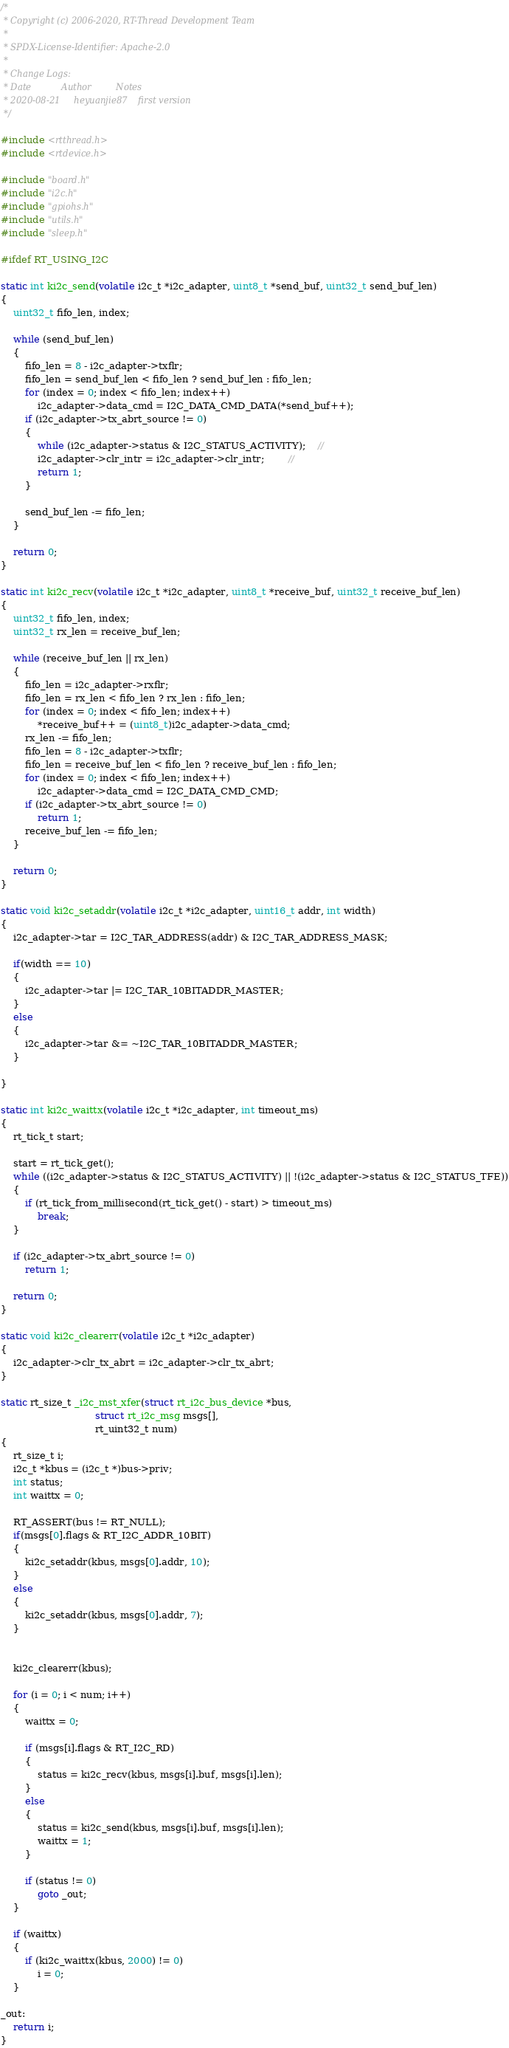Convert code to text. <code><loc_0><loc_0><loc_500><loc_500><_C_>/*
 * Copyright (c) 2006-2020, RT-Thread Development Team
 *
 * SPDX-License-Identifier: Apache-2.0
 *
 * Change Logs:
 * Date           Author         Notes
 * 2020-08-21     heyuanjie87    first version
 */

#include <rtthread.h>
#include <rtdevice.h>

#include "board.h"
#include "i2c.h"
#include "gpiohs.h"
#include "utils.h"
#include "sleep.h"

#ifdef RT_USING_I2C

static int ki2c_send(volatile i2c_t *i2c_adapter, uint8_t *send_buf, uint32_t send_buf_len)
{
    uint32_t fifo_len, index;

    while (send_buf_len)
    {
        fifo_len = 8 - i2c_adapter->txflr;
        fifo_len = send_buf_len < fifo_len ? send_buf_len : fifo_len;
        for (index = 0; index < fifo_len; index++)
            i2c_adapter->data_cmd = I2C_DATA_CMD_DATA(*send_buf++);
        if (i2c_adapter->tx_abrt_source != 0)
        {
            while (i2c_adapter->status & I2C_STATUS_ACTIVITY);	//
            i2c_adapter->clr_intr = i2c_adapter->clr_intr;		//
            return 1;
        }

        send_buf_len -= fifo_len;
    }

    return 0;
}

static int ki2c_recv(volatile i2c_t *i2c_adapter, uint8_t *receive_buf, uint32_t receive_buf_len)
{
    uint32_t fifo_len, index;
    uint32_t rx_len = receive_buf_len;

    while (receive_buf_len || rx_len)
    {
        fifo_len = i2c_adapter->rxflr;
        fifo_len = rx_len < fifo_len ? rx_len : fifo_len;
        for (index = 0; index < fifo_len; index++)
            *receive_buf++ = (uint8_t)i2c_adapter->data_cmd;
        rx_len -= fifo_len;
        fifo_len = 8 - i2c_adapter->txflr;
        fifo_len = receive_buf_len < fifo_len ? receive_buf_len : fifo_len;
        for (index = 0; index < fifo_len; index++)
            i2c_adapter->data_cmd = I2C_DATA_CMD_CMD;
        if (i2c_adapter->tx_abrt_source != 0)
            return 1;
        receive_buf_len -= fifo_len;
    }

    return 0;
}

static void ki2c_setaddr(volatile i2c_t *i2c_adapter, uint16_t addr, int width)
{
    i2c_adapter->tar = I2C_TAR_ADDRESS(addr) & I2C_TAR_ADDRESS_MASK;

    if(width == 10)
    {
        i2c_adapter->tar |= I2C_TAR_10BITADDR_MASTER;
    }
    else
    {
        i2c_adapter->tar &= ~I2C_TAR_10BITADDR_MASTER;
    }
    
}

static int ki2c_waittx(volatile i2c_t *i2c_adapter, int timeout_ms)
{
    rt_tick_t start;

    start = rt_tick_get();
    while ((i2c_adapter->status & I2C_STATUS_ACTIVITY) || !(i2c_adapter->status & I2C_STATUS_TFE))
    {
        if (rt_tick_from_millisecond(rt_tick_get() - start) > timeout_ms)
            break;
    }

    if (i2c_adapter->tx_abrt_source != 0)
        return 1;

    return 0;
}

static void ki2c_clearerr(volatile i2c_t *i2c_adapter)
{
    i2c_adapter->clr_tx_abrt = i2c_adapter->clr_tx_abrt;
}

static rt_size_t _i2c_mst_xfer(struct rt_i2c_bus_device *bus,
                               struct rt_i2c_msg msgs[],
                               rt_uint32_t num)
{
    rt_size_t i;
    i2c_t *kbus = (i2c_t *)bus->priv;
    int status;
    int waittx = 0;

    RT_ASSERT(bus != RT_NULL);
    if(msgs[0].flags & RT_I2C_ADDR_10BIT)
    {
        ki2c_setaddr(kbus, msgs[0].addr, 10);
    }
    else
    {
        ki2c_setaddr(kbus, msgs[0].addr, 7);
    }
    
    
    ki2c_clearerr(kbus);

    for (i = 0; i < num; i++)
    {
        waittx = 0;

        if (msgs[i].flags & RT_I2C_RD)
        {
            status = ki2c_recv(kbus, msgs[i].buf, msgs[i].len);
        }
        else
        {
            status = ki2c_send(kbus, msgs[i].buf, msgs[i].len);
            waittx = 1;
        }

        if (status != 0)
            goto _out;
    }

    if (waittx)
    {
        if (ki2c_waittx(kbus, 2000) != 0)
            i = 0;
    }

_out:
    return i;
}
</code> 